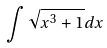Convert formula to latex. <formula><loc_0><loc_0><loc_500><loc_500>\int \sqrt { x ^ { 3 } + 1 } d x</formula> 